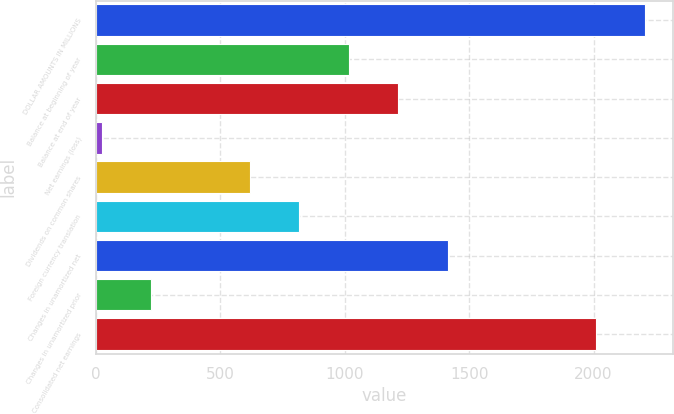<chart> <loc_0><loc_0><loc_500><loc_500><bar_chart><fcel>DOLLAR AMOUNTS IN MILLIONS<fcel>Balance at beginning of year<fcel>Balance at end of year<fcel>Net earnings (loss)<fcel>Dividends on common shares<fcel>Foreign currency translation<fcel>Changes in unamortized net<fcel>Changes in unamortized prior<fcel>Consolidated net earnings<nl><fcel>2207.6<fcel>1016<fcel>1214.6<fcel>23<fcel>618.8<fcel>817.4<fcel>1413.2<fcel>221.6<fcel>2009<nl></chart> 